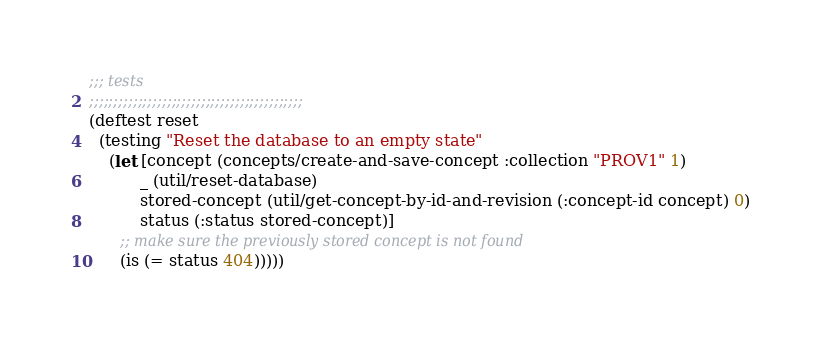<code> <loc_0><loc_0><loc_500><loc_500><_Clojure_>;;; tests
;;;;;;;;;;;;;;;;;;;;;;;;;;;;;;;;;;;;;;;;;;;;
(deftest reset
  (testing "Reset the database to an empty state"
    (let [concept (concepts/create-and-save-concept :collection "PROV1" 1)
          _ (util/reset-database)
          stored-concept (util/get-concept-by-id-and-revision (:concept-id concept) 0)
          status (:status stored-concept)]
      ;; make sure the previously stored concept is not found
      (is (= status 404)))))
</code> 